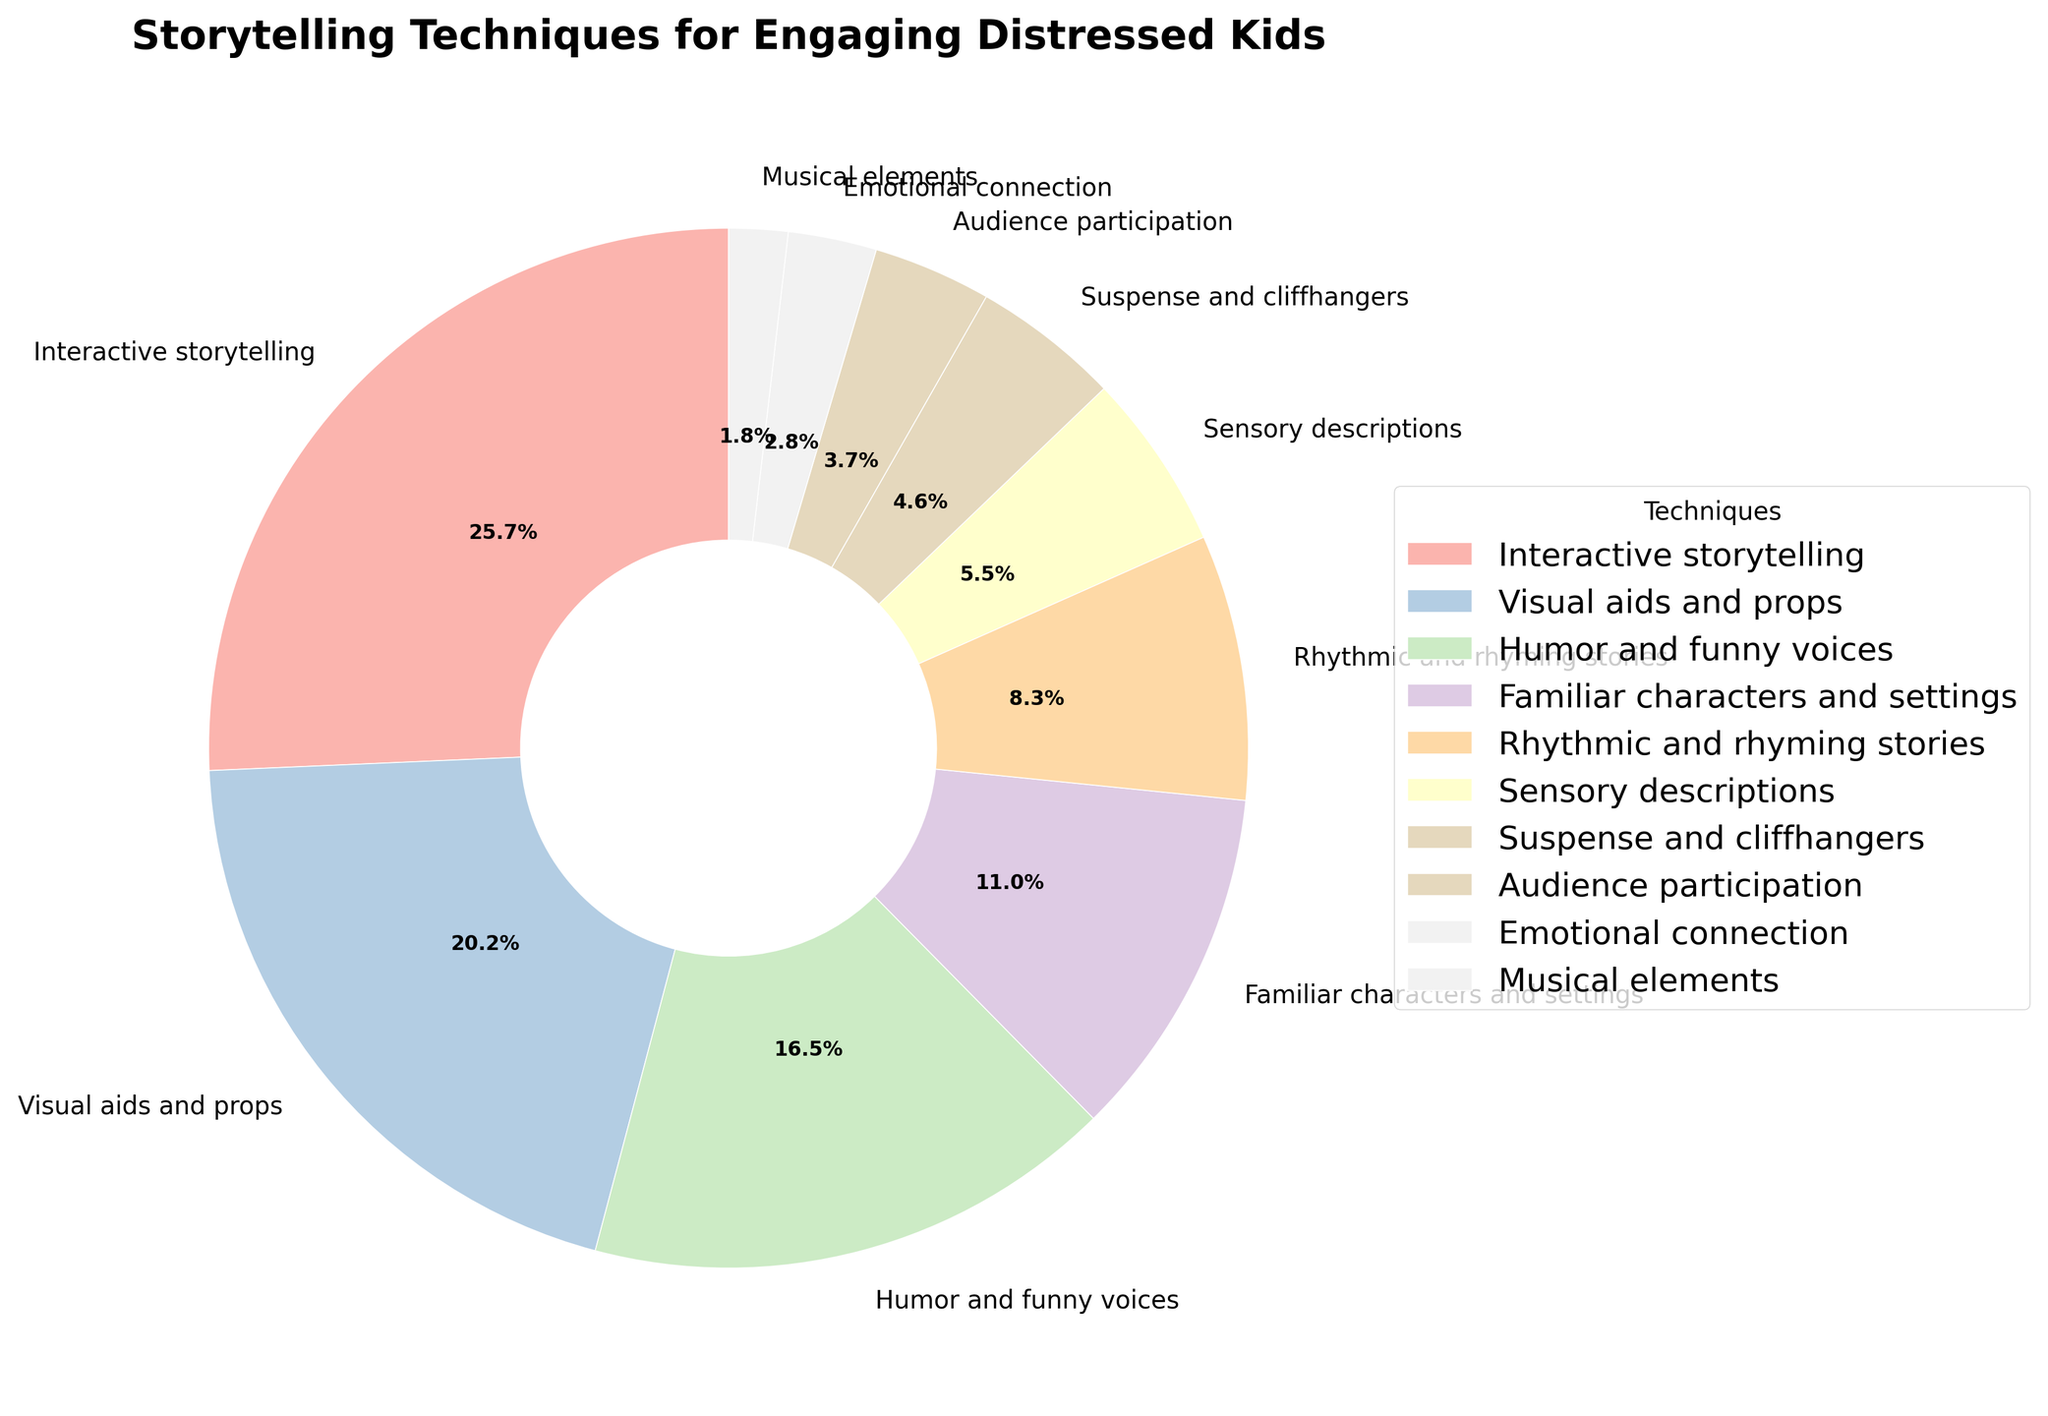What percentage of storytelling techniques is contributed by Interactive storytelling? Interactive storytelling contributes 28% of the total storytelling techniques. This is directly visible from the pie chart as the slice labeled "Interactive storytelling" is 28%.
Answer: 28% Which storytelling technique uses props and visual aids? The slice labeled "Visual aids and props" indicates that this technique uses props and aids, contributing 22% to the total techniques.
Answer: Visual aids and props What is the combined percentage of Humor and funny voices, Rhythmic and rhyming stories, and Emotional connection techniques? The individual percentages for Humor and funny voices (18%), Rhythmic and rhyming stories (9%), and Emotional connection (3%) add up to a combined total of 18 + 9 + 3 = 30%.
Answer: 30% How does the percentage of Familiar characters and settings compare to Sensory descriptions? Familiar characters and settings contribute 12%, whereas Sensory descriptions contribute 6%. Therefore, Familiar characters and settings are twice as much as Sensory descriptions (12% vs. 6%).
Answer: Familiar characters and settings is 2 times more than Sensory descriptions Identify the technique that contributes the least percentage. Musical elements contribute the least percentage, with only 2% of the total storytelling techniques. This is directly identifiable from the pie chart as the smallest slice labeled "Musical elements".
Answer: Musical elements Calculate the difference in percentage between Suspense and cliffhangers and Audience participation techniques. Suspense and cliffhangers contribute 5%, whereas Audience participation contributes 4%. The difference is 5% - 4% = 1%.
Answer: 1% How much more do Interactive storytelling and Visual aids and props combined contribute compared to Suspense and cliffhangers and Emotional connection combined? Interactive storytelling (28%) and Visual aids and props (22%) combined contribute 28 + 22 = 50%. Suspense and cliffhangers (5%) and Emotional connection (3%) combined contribute 5 + 3 = 8%. The difference is 50% - 8% = 42%.
Answer: 42% Which technique's slice has a similar color to the Suspense and cliffhangers slice? We observe the colors of the slices: Suspense and cliffhangers have a distinct visual color. We look for a similar hue or shade in another slice. Upon examination, the most similar color would be the one that appears in the visually represented chart closest to it. Given the provided context focusing on natural language, it’s something one would need to point out visually rather than numerically, hence dependent on the chart’s design.
Answer: N/A Which is greater: the sum of Visual aids and props and Rhythmic and rhyming stories, or the sum of Humor and funny voices and Sensory descriptions? Visual aids and props (22%) + Rhythmic and rhyming stories (9%) = 31%. Humor and funny voices (18%) + Sensory descriptions (6%) = 24%. Hence, 31% (sum of Visual aids and props and Rhythmic and rhyming stories) is greater than 24% (sum of Humor and funny voices and Sensory descriptions).
Answer: Sum of Visual aids and props and Rhythmic and rhyming stories What is the visual color difference between Emotional connection and Audience participation slices? We can observe the color shades used in the pie chart: Emotional connection's color would visually differ from Audience participation's color based on the design intent (e.g., lightness, saturation). Given the category difference (one at 3% and another at 4%), there might be distinguishable visual variances ensuring categorical differentiation (perhaps in lighter hues or slightly varied pastel tones).
Answer: N/A 